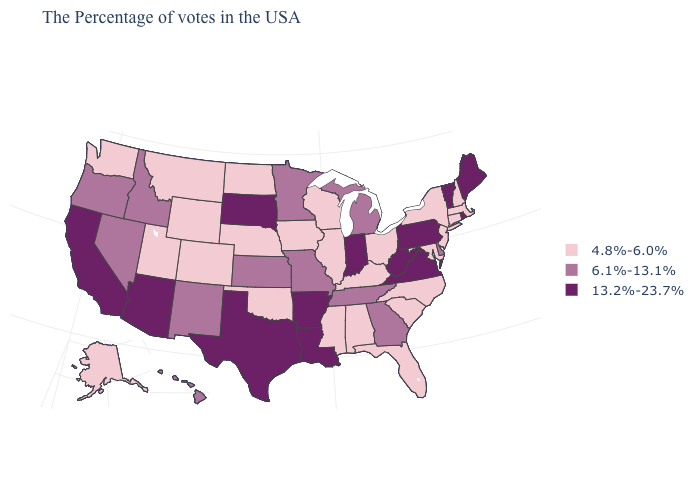Among the states that border Mississippi , does Alabama have the lowest value?
Answer briefly. Yes. Name the states that have a value in the range 13.2%-23.7%?
Be succinct. Maine, Rhode Island, Vermont, Pennsylvania, Virginia, West Virginia, Indiana, Louisiana, Arkansas, Texas, South Dakota, Arizona, California. Does the map have missing data?
Quick response, please. No. Name the states that have a value in the range 6.1%-13.1%?
Short answer required. Delaware, Georgia, Michigan, Tennessee, Missouri, Minnesota, Kansas, New Mexico, Idaho, Nevada, Oregon, Hawaii. Is the legend a continuous bar?
Be succinct. No. What is the value of Washington?
Be succinct. 4.8%-6.0%. Name the states that have a value in the range 4.8%-6.0%?
Short answer required. Massachusetts, New Hampshire, Connecticut, New York, New Jersey, Maryland, North Carolina, South Carolina, Ohio, Florida, Kentucky, Alabama, Wisconsin, Illinois, Mississippi, Iowa, Nebraska, Oklahoma, North Dakota, Wyoming, Colorado, Utah, Montana, Washington, Alaska. Does Massachusetts have a higher value than Iowa?
Answer briefly. No. What is the highest value in the USA?
Keep it brief. 13.2%-23.7%. Which states have the highest value in the USA?
Write a very short answer. Maine, Rhode Island, Vermont, Pennsylvania, Virginia, West Virginia, Indiana, Louisiana, Arkansas, Texas, South Dakota, Arizona, California. What is the value of Pennsylvania?
Write a very short answer. 13.2%-23.7%. What is the value of New Hampshire?
Answer briefly. 4.8%-6.0%. What is the highest value in the Northeast ?
Quick response, please. 13.2%-23.7%. What is the value of South Dakota?
Be succinct. 13.2%-23.7%. Name the states that have a value in the range 13.2%-23.7%?
Be succinct. Maine, Rhode Island, Vermont, Pennsylvania, Virginia, West Virginia, Indiana, Louisiana, Arkansas, Texas, South Dakota, Arizona, California. 